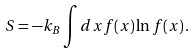Convert formula to latex. <formula><loc_0><loc_0><loc_500><loc_500>S = - k _ { B } \int d x f ( x ) \ln f ( x ) \, .</formula> 